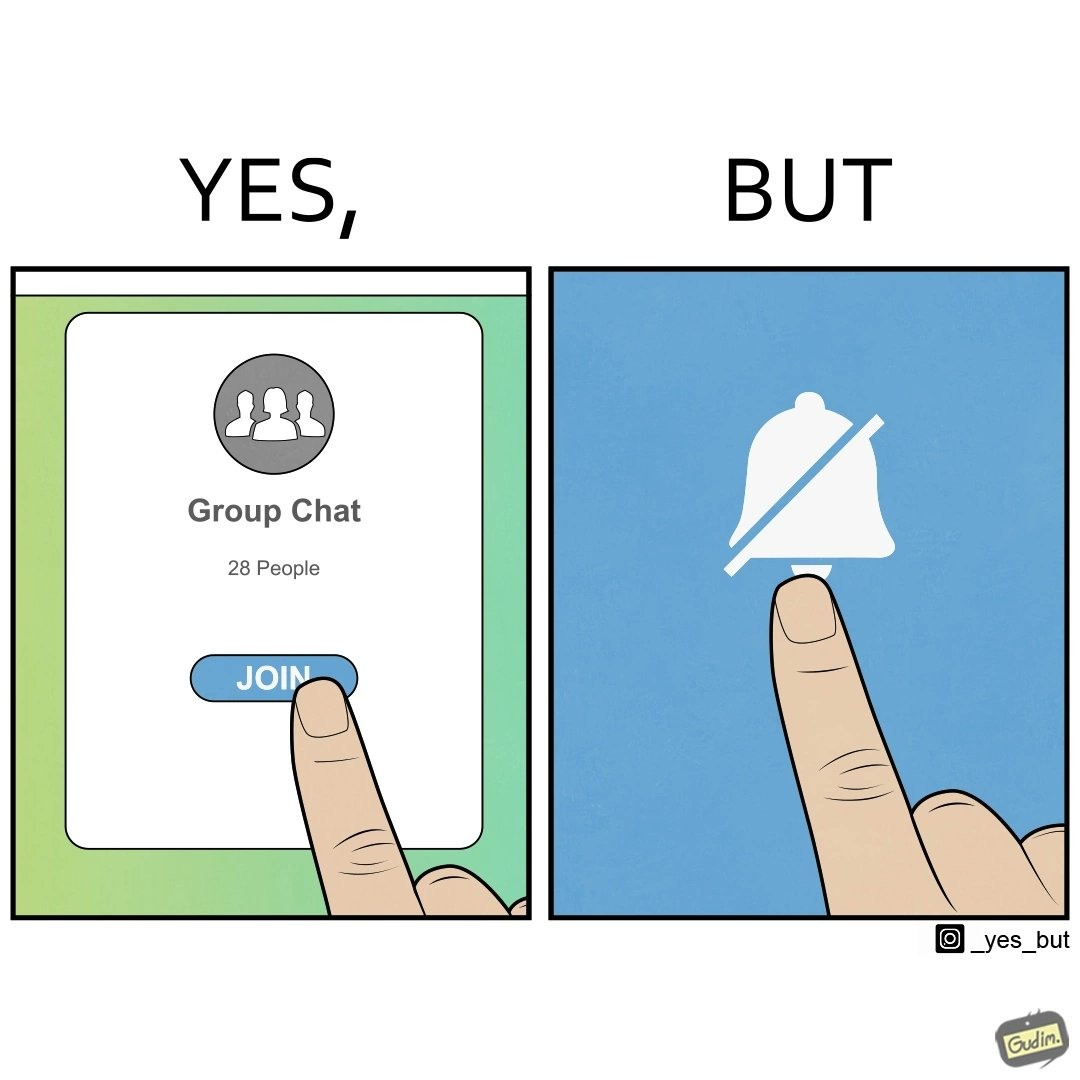What is shown in this image? This is ironic because the person joining the big social group, presumably interested in the happenings of that group, motivated to engage with these people, MUTEs the group as soon as they join it, indicating they are not interested in it and do not  want to be bothered by it.  These actions are contradictory from a social perspective, and illuminate a weird fact about present day online life. 